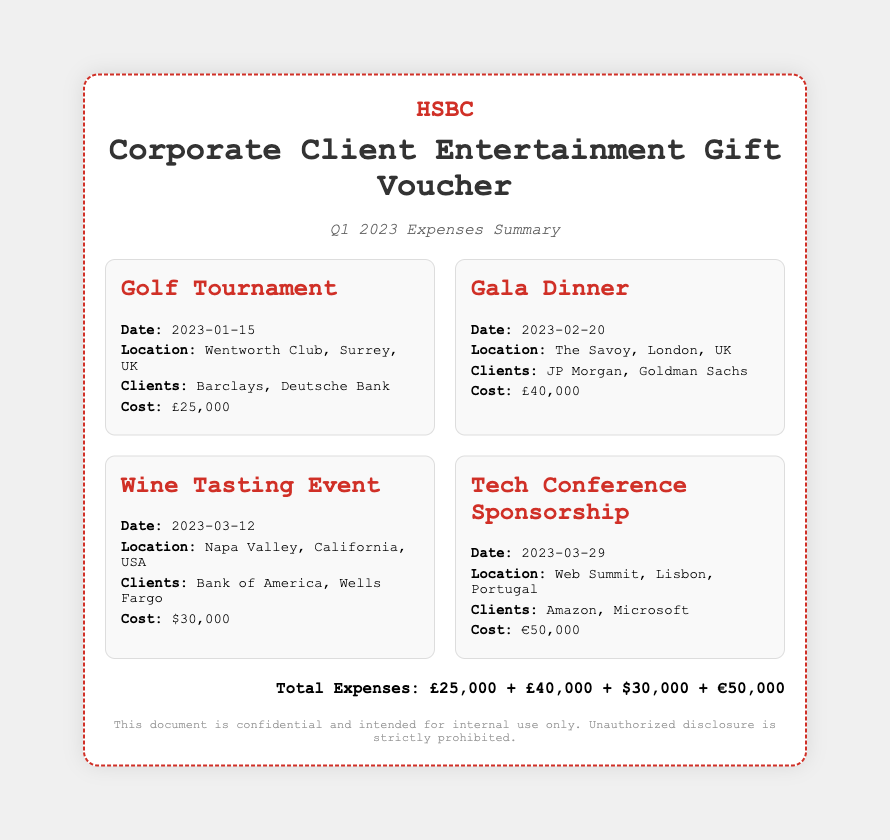What is the date of the Golf Tournament? The Golf Tournament is dated January 15, 2023, as stated in the event details.
Answer: January 15, 2023 Who were the clients at the Gala Dinner? The clients mentioned for the Gala Dinner are JP Morgan and Goldman Sachs.
Answer: JP Morgan, Goldman Sachs What was the cost of the Wine Tasting Event? The cost associated with the Wine Tasting Event is listed as $30,000.
Answer: $30,000 What is the total cost for the Tech Conference Sponsorship? The document states that the cost for the Tech Conference Sponsorship is €50,000.
Answer: €50,000 How many events are listed in the document? The document outlines a total of four events in the event list.
Answer: Four What is the total expenses calculated from the listed events? The total expenses consist of the individual expenses outlined for each event.
Answer: £25,000 + £40,000 + $30,000 + €50,000 What is the location of the Wine Tasting Event? The document indicates that the Wine Tasting Event is held in Napa Valley, California, USA.
Answer: Napa Valley, California, USA Which clients attended the Golf Tournament? Barclays and Deutsche Bank are the clients stated for the Golf Tournament.
Answer: Barclays, Deutsche Bank 